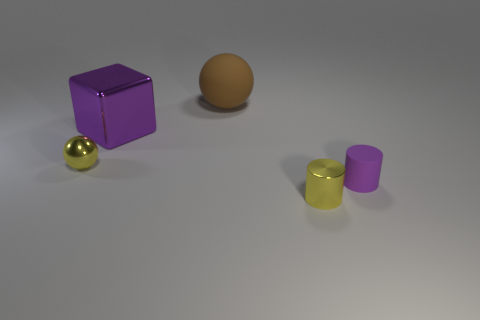Are there the same number of tiny purple cylinders left of the small yellow metallic sphere and matte balls?
Provide a succinct answer. No. Are the small thing that is in front of the small rubber cylinder and the big purple block right of the tiny yellow metal sphere made of the same material?
Provide a short and direct response. Yes. There is a small metal thing in front of the rubber object that is on the right side of the rubber sphere; what is its shape?
Provide a short and direct response. Cylinder. What color is the block that is the same material as the yellow sphere?
Give a very brief answer. Purple. Do the metal cube and the small shiny ball have the same color?
Give a very brief answer. No. What is the shape of the other shiny thing that is the same size as the brown thing?
Ensure brevity in your answer.  Cube. What is the size of the rubber ball?
Keep it short and to the point. Large. Does the shiny thing in front of the small sphere have the same size as the purple object on the right side of the small metal cylinder?
Your answer should be compact. Yes. There is a small shiny object that is behind the small yellow metallic object in front of the rubber cylinder; what is its color?
Make the answer very short. Yellow. What material is the brown object that is the same size as the purple metal block?
Your answer should be very brief. Rubber. 